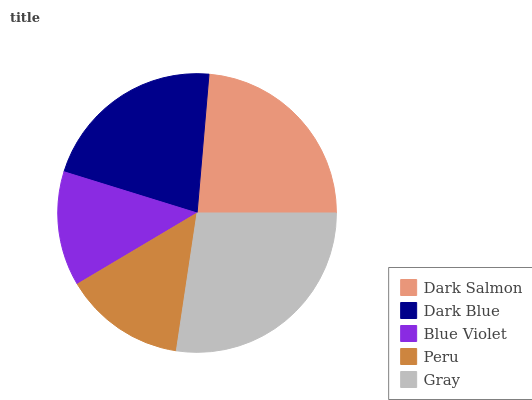Is Blue Violet the minimum?
Answer yes or no. Yes. Is Gray the maximum?
Answer yes or no. Yes. Is Dark Blue the minimum?
Answer yes or no. No. Is Dark Blue the maximum?
Answer yes or no. No. Is Dark Salmon greater than Dark Blue?
Answer yes or no. Yes. Is Dark Blue less than Dark Salmon?
Answer yes or no. Yes. Is Dark Blue greater than Dark Salmon?
Answer yes or no. No. Is Dark Salmon less than Dark Blue?
Answer yes or no. No. Is Dark Blue the high median?
Answer yes or no. Yes. Is Dark Blue the low median?
Answer yes or no. Yes. Is Gray the high median?
Answer yes or no. No. Is Blue Violet the low median?
Answer yes or no. No. 